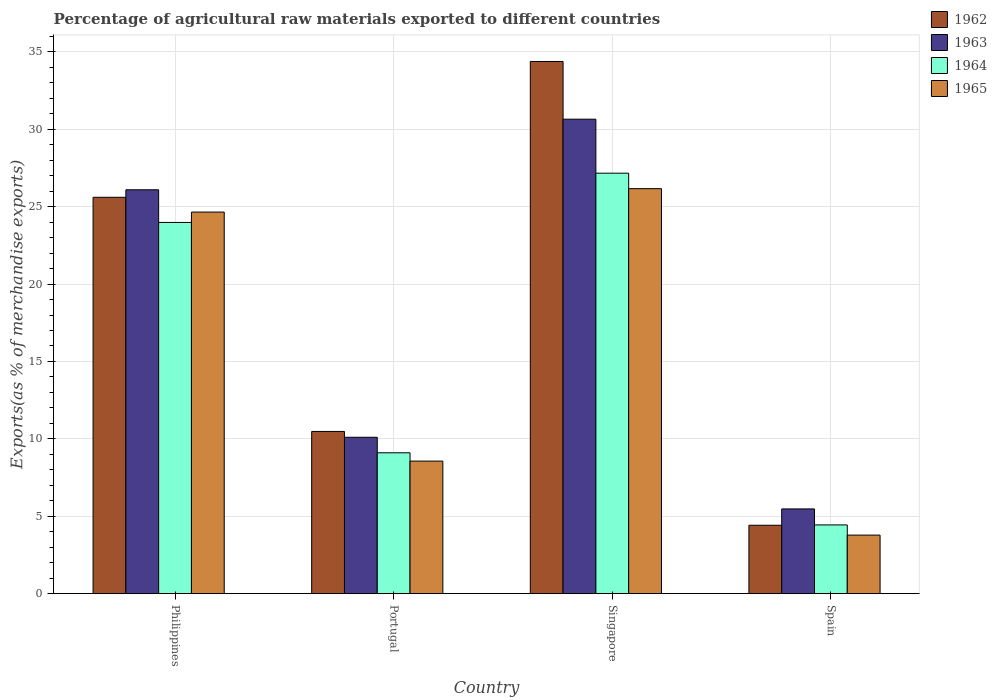Are the number of bars per tick equal to the number of legend labels?
Make the answer very short. Yes. Are the number of bars on each tick of the X-axis equal?
Make the answer very short. Yes. How many bars are there on the 1st tick from the left?
Give a very brief answer. 4. How many bars are there on the 4th tick from the right?
Your response must be concise. 4. What is the label of the 4th group of bars from the left?
Your response must be concise. Spain. In how many cases, is the number of bars for a given country not equal to the number of legend labels?
Provide a succinct answer. 0. What is the percentage of exports to different countries in 1965 in Philippines?
Provide a succinct answer. 24.65. Across all countries, what is the maximum percentage of exports to different countries in 1964?
Ensure brevity in your answer.  27.16. Across all countries, what is the minimum percentage of exports to different countries in 1963?
Ensure brevity in your answer.  5.47. In which country was the percentage of exports to different countries in 1964 maximum?
Ensure brevity in your answer.  Singapore. In which country was the percentage of exports to different countries in 1962 minimum?
Offer a very short reply. Spain. What is the total percentage of exports to different countries in 1962 in the graph?
Your answer should be very brief. 74.88. What is the difference between the percentage of exports to different countries in 1965 in Philippines and that in Spain?
Give a very brief answer. 20.86. What is the difference between the percentage of exports to different countries in 1964 in Singapore and the percentage of exports to different countries in 1962 in Portugal?
Offer a very short reply. 16.68. What is the average percentage of exports to different countries in 1962 per country?
Give a very brief answer. 18.72. What is the difference between the percentage of exports to different countries of/in 1965 and percentage of exports to different countries of/in 1962 in Philippines?
Your answer should be compact. -0.96. In how many countries, is the percentage of exports to different countries in 1965 greater than 29 %?
Your answer should be very brief. 0. What is the ratio of the percentage of exports to different countries in 1962 in Philippines to that in Spain?
Provide a short and direct response. 5.79. Is the difference between the percentage of exports to different countries in 1965 in Philippines and Portugal greater than the difference between the percentage of exports to different countries in 1962 in Philippines and Portugal?
Give a very brief answer. Yes. What is the difference between the highest and the second highest percentage of exports to different countries in 1963?
Keep it short and to the point. 15.99. What is the difference between the highest and the lowest percentage of exports to different countries in 1965?
Your answer should be very brief. 22.38. Is the sum of the percentage of exports to different countries in 1964 in Singapore and Spain greater than the maximum percentage of exports to different countries in 1962 across all countries?
Ensure brevity in your answer.  No. Is it the case that in every country, the sum of the percentage of exports to different countries in 1962 and percentage of exports to different countries in 1964 is greater than the sum of percentage of exports to different countries in 1965 and percentage of exports to different countries in 1963?
Provide a succinct answer. No. What does the 3rd bar from the left in Portugal represents?
Keep it short and to the point. 1964. What does the 3rd bar from the right in Spain represents?
Keep it short and to the point. 1963. Does the graph contain any zero values?
Your response must be concise. No. Where does the legend appear in the graph?
Your response must be concise. Top right. What is the title of the graph?
Provide a succinct answer. Percentage of agricultural raw materials exported to different countries. What is the label or title of the Y-axis?
Your response must be concise. Exports(as % of merchandise exports). What is the Exports(as % of merchandise exports) in 1962 in Philippines?
Provide a short and direct response. 25.6. What is the Exports(as % of merchandise exports) of 1963 in Philippines?
Offer a terse response. 26.09. What is the Exports(as % of merchandise exports) of 1964 in Philippines?
Your response must be concise. 23.98. What is the Exports(as % of merchandise exports) in 1965 in Philippines?
Make the answer very short. 24.65. What is the Exports(as % of merchandise exports) in 1962 in Portugal?
Make the answer very short. 10.48. What is the Exports(as % of merchandise exports) of 1963 in Portugal?
Give a very brief answer. 10.1. What is the Exports(as % of merchandise exports) in 1964 in Portugal?
Your answer should be very brief. 9.1. What is the Exports(as % of merchandise exports) in 1965 in Portugal?
Offer a terse response. 8.56. What is the Exports(as % of merchandise exports) in 1962 in Singapore?
Provide a short and direct response. 34.38. What is the Exports(as % of merchandise exports) of 1963 in Singapore?
Offer a terse response. 30.65. What is the Exports(as % of merchandise exports) of 1964 in Singapore?
Provide a succinct answer. 27.16. What is the Exports(as % of merchandise exports) in 1965 in Singapore?
Provide a short and direct response. 26.16. What is the Exports(as % of merchandise exports) of 1962 in Spain?
Your answer should be compact. 4.42. What is the Exports(as % of merchandise exports) in 1963 in Spain?
Your response must be concise. 5.47. What is the Exports(as % of merchandise exports) in 1964 in Spain?
Offer a very short reply. 4.44. What is the Exports(as % of merchandise exports) of 1965 in Spain?
Offer a very short reply. 3.78. Across all countries, what is the maximum Exports(as % of merchandise exports) in 1962?
Your answer should be very brief. 34.38. Across all countries, what is the maximum Exports(as % of merchandise exports) of 1963?
Offer a terse response. 30.65. Across all countries, what is the maximum Exports(as % of merchandise exports) of 1964?
Keep it short and to the point. 27.16. Across all countries, what is the maximum Exports(as % of merchandise exports) in 1965?
Your response must be concise. 26.16. Across all countries, what is the minimum Exports(as % of merchandise exports) of 1962?
Give a very brief answer. 4.42. Across all countries, what is the minimum Exports(as % of merchandise exports) in 1963?
Give a very brief answer. 5.47. Across all countries, what is the minimum Exports(as % of merchandise exports) of 1964?
Your answer should be very brief. 4.44. Across all countries, what is the minimum Exports(as % of merchandise exports) in 1965?
Provide a short and direct response. 3.78. What is the total Exports(as % of merchandise exports) of 1962 in the graph?
Make the answer very short. 74.88. What is the total Exports(as % of merchandise exports) in 1963 in the graph?
Give a very brief answer. 72.31. What is the total Exports(as % of merchandise exports) in 1964 in the graph?
Ensure brevity in your answer.  64.68. What is the total Exports(as % of merchandise exports) of 1965 in the graph?
Keep it short and to the point. 63.15. What is the difference between the Exports(as % of merchandise exports) of 1962 in Philippines and that in Portugal?
Provide a succinct answer. 15.13. What is the difference between the Exports(as % of merchandise exports) of 1963 in Philippines and that in Portugal?
Provide a short and direct response. 15.99. What is the difference between the Exports(as % of merchandise exports) of 1964 in Philippines and that in Portugal?
Keep it short and to the point. 14.88. What is the difference between the Exports(as % of merchandise exports) in 1965 in Philippines and that in Portugal?
Make the answer very short. 16.08. What is the difference between the Exports(as % of merchandise exports) in 1962 in Philippines and that in Singapore?
Make the answer very short. -8.77. What is the difference between the Exports(as % of merchandise exports) in 1963 in Philippines and that in Singapore?
Keep it short and to the point. -4.56. What is the difference between the Exports(as % of merchandise exports) of 1964 in Philippines and that in Singapore?
Your response must be concise. -3.18. What is the difference between the Exports(as % of merchandise exports) in 1965 in Philippines and that in Singapore?
Provide a succinct answer. -1.51. What is the difference between the Exports(as % of merchandise exports) in 1962 in Philippines and that in Spain?
Your answer should be very brief. 21.19. What is the difference between the Exports(as % of merchandise exports) of 1963 in Philippines and that in Spain?
Ensure brevity in your answer.  20.62. What is the difference between the Exports(as % of merchandise exports) in 1964 in Philippines and that in Spain?
Ensure brevity in your answer.  19.54. What is the difference between the Exports(as % of merchandise exports) in 1965 in Philippines and that in Spain?
Your response must be concise. 20.86. What is the difference between the Exports(as % of merchandise exports) in 1962 in Portugal and that in Singapore?
Offer a terse response. -23.9. What is the difference between the Exports(as % of merchandise exports) in 1963 in Portugal and that in Singapore?
Provide a short and direct response. -20.55. What is the difference between the Exports(as % of merchandise exports) of 1964 in Portugal and that in Singapore?
Offer a terse response. -18.06. What is the difference between the Exports(as % of merchandise exports) of 1965 in Portugal and that in Singapore?
Offer a very short reply. -17.6. What is the difference between the Exports(as % of merchandise exports) in 1962 in Portugal and that in Spain?
Offer a terse response. 6.06. What is the difference between the Exports(as % of merchandise exports) of 1963 in Portugal and that in Spain?
Offer a terse response. 4.63. What is the difference between the Exports(as % of merchandise exports) of 1964 in Portugal and that in Spain?
Ensure brevity in your answer.  4.66. What is the difference between the Exports(as % of merchandise exports) in 1965 in Portugal and that in Spain?
Your response must be concise. 4.78. What is the difference between the Exports(as % of merchandise exports) of 1962 in Singapore and that in Spain?
Offer a very short reply. 29.96. What is the difference between the Exports(as % of merchandise exports) of 1963 in Singapore and that in Spain?
Provide a succinct answer. 25.18. What is the difference between the Exports(as % of merchandise exports) of 1964 in Singapore and that in Spain?
Your answer should be very brief. 22.72. What is the difference between the Exports(as % of merchandise exports) in 1965 in Singapore and that in Spain?
Your answer should be very brief. 22.38. What is the difference between the Exports(as % of merchandise exports) of 1962 in Philippines and the Exports(as % of merchandise exports) of 1963 in Portugal?
Give a very brief answer. 15.5. What is the difference between the Exports(as % of merchandise exports) of 1962 in Philippines and the Exports(as % of merchandise exports) of 1964 in Portugal?
Your answer should be very brief. 16.5. What is the difference between the Exports(as % of merchandise exports) in 1962 in Philippines and the Exports(as % of merchandise exports) in 1965 in Portugal?
Make the answer very short. 17.04. What is the difference between the Exports(as % of merchandise exports) of 1963 in Philippines and the Exports(as % of merchandise exports) of 1964 in Portugal?
Give a very brief answer. 16.99. What is the difference between the Exports(as % of merchandise exports) in 1963 in Philippines and the Exports(as % of merchandise exports) in 1965 in Portugal?
Keep it short and to the point. 17.53. What is the difference between the Exports(as % of merchandise exports) in 1964 in Philippines and the Exports(as % of merchandise exports) in 1965 in Portugal?
Your answer should be very brief. 15.42. What is the difference between the Exports(as % of merchandise exports) of 1962 in Philippines and the Exports(as % of merchandise exports) of 1963 in Singapore?
Offer a very short reply. -5.04. What is the difference between the Exports(as % of merchandise exports) of 1962 in Philippines and the Exports(as % of merchandise exports) of 1964 in Singapore?
Your answer should be very brief. -1.56. What is the difference between the Exports(as % of merchandise exports) in 1962 in Philippines and the Exports(as % of merchandise exports) in 1965 in Singapore?
Your answer should be compact. -0.56. What is the difference between the Exports(as % of merchandise exports) of 1963 in Philippines and the Exports(as % of merchandise exports) of 1964 in Singapore?
Give a very brief answer. -1.07. What is the difference between the Exports(as % of merchandise exports) in 1963 in Philippines and the Exports(as % of merchandise exports) in 1965 in Singapore?
Offer a terse response. -0.07. What is the difference between the Exports(as % of merchandise exports) in 1964 in Philippines and the Exports(as % of merchandise exports) in 1965 in Singapore?
Make the answer very short. -2.18. What is the difference between the Exports(as % of merchandise exports) of 1962 in Philippines and the Exports(as % of merchandise exports) of 1963 in Spain?
Ensure brevity in your answer.  20.13. What is the difference between the Exports(as % of merchandise exports) of 1962 in Philippines and the Exports(as % of merchandise exports) of 1964 in Spain?
Give a very brief answer. 21.16. What is the difference between the Exports(as % of merchandise exports) in 1962 in Philippines and the Exports(as % of merchandise exports) in 1965 in Spain?
Provide a succinct answer. 21.82. What is the difference between the Exports(as % of merchandise exports) of 1963 in Philippines and the Exports(as % of merchandise exports) of 1964 in Spain?
Offer a very short reply. 21.65. What is the difference between the Exports(as % of merchandise exports) of 1963 in Philippines and the Exports(as % of merchandise exports) of 1965 in Spain?
Your answer should be very brief. 22.31. What is the difference between the Exports(as % of merchandise exports) of 1964 in Philippines and the Exports(as % of merchandise exports) of 1965 in Spain?
Offer a very short reply. 20.2. What is the difference between the Exports(as % of merchandise exports) in 1962 in Portugal and the Exports(as % of merchandise exports) in 1963 in Singapore?
Your response must be concise. -20.17. What is the difference between the Exports(as % of merchandise exports) of 1962 in Portugal and the Exports(as % of merchandise exports) of 1964 in Singapore?
Provide a short and direct response. -16.68. What is the difference between the Exports(as % of merchandise exports) of 1962 in Portugal and the Exports(as % of merchandise exports) of 1965 in Singapore?
Your answer should be very brief. -15.68. What is the difference between the Exports(as % of merchandise exports) in 1963 in Portugal and the Exports(as % of merchandise exports) in 1964 in Singapore?
Provide a short and direct response. -17.06. What is the difference between the Exports(as % of merchandise exports) in 1963 in Portugal and the Exports(as % of merchandise exports) in 1965 in Singapore?
Your answer should be compact. -16.06. What is the difference between the Exports(as % of merchandise exports) in 1964 in Portugal and the Exports(as % of merchandise exports) in 1965 in Singapore?
Keep it short and to the point. -17.06. What is the difference between the Exports(as % of merchandise exports) in 1962 in Portugal and the Exports(as % of merchandise exports) in 1963 in Spain?
Your answer should be compact. 5. What is the difference between the Exports(as % of merchandise exports) in 1962 in Portugal and the Exports(as % of merchandise exports) in 1964 in Spain?
Offer a very short reply. 6.04. What is the difference between the Exports(as % of merchandise exports) in 1962 in Portugal and the Exports(as % of merchandise exports) in 1965 in Spain?
Your response must be concise. 6.7. What is the difference between the Exports(as % of merchandise exports) of 1963 in Portugal and the Exports(as % of merchandise exports) of 1964 in Spain?
Your response must be concise. 5.66. What is the difference between the Exports(as % of merchandise exports) in 1963 in Portugal and the Exports(as % of merchandise exports) in 1965 in Spain?
Keep it short and to the point. 6.32. What is the difference between the Exports(as % of merchandise exports) in 1964 in Portugal and the Exports(as % of merchandise exports) in 1965 in Spain?
Make the answer very short. 5.32. What is the difference between the Exports(as % of merchandise exports) of 1962 in Singapore and the Exports(as % of merchandise exports) of 1963 in Spain?
Offer a very short reply. 28.9. What is the difference between the Exports(as % of merchandise exports) of 1962 in Singapore and the Exports(as % of merchandise exports) of 1964 in Spain?
Your answer should be compact. 29.94. What is the difference between the Exports(as % of merchandise exports) of 1962 in Singapore and the Exports(as % of merchandise exports) of 1965 in Spain?
Your answer should be very brief. 30.59. What is the difference between the Exports(as % of merchandise exports) in 1963 in Singapore and the Exports(as % of merchandise exports) in 1964 in Spain?
Keep it short and to the point. 26.21. What is the difference between the Exports(as % of merchandise exports) of 1963 in Singapore and the Exports(as % of merchandise exports) of 1965 in Spain?
Offer a terse response. 26.87. What is the difference between the Exports(as % of merchandise exports) in 1964 in Singapore and the Exports(as % of merchandise exports) in 1965 in Spain?
Your answer should be compact. 23.38. What is the average Exports(as % of merchandise exports) in 1962 per country?
Provide a short and direct response. 18.72. What is the average Exports(as % of merchandise exports) of 1963 per country?
Your answer should be compact. 18.08. What is the average Exports(as % of merchandise exports) of 1964 per country?
Provide a succinct answer. 16.17. What is the average Exports(as % of merchandise exports) in 1965 per country?
Provide a short and direct response. 15.79. What is the difference between the Exports(as % of merchandise exports) of 1962 and Exports(as % of merchandise exports) of 1963 in Philippines?
Give a very brief answer. -0.49. What is the difference between the Exports(as % of merchandise exports) of 1962 and Exports(as % of merchandise exports) of 1964 in Philippines?
Provide a short and direct response. 1.63. What is the difference between the Exports(as % of merchandise exports) of 1962 and Exports(as % of merchandise exports) of 1965 in Philippines?
Ensure brevity in your answer.  0.96. What is the difference between the Exports(as % of merchandise exports) of 1963 and Exports(as % of merchandise exports) of 1964 in Philippines?
Your answer should be compact. 2.11. What is the difference between the Exports(as % of merchandise exports) of 1963 and Exports(as % of merchandise exports) of 1965 in Philippines?
Provide a succinct answer. 1.44. What is the difference between the Exports(as % of merchandise exports) in 1964 and Exports(as % of merchandise exports) in 1965 in Philippines?
Provide a short and direct response. -0.67. What is the difference between the Exports(as % of merchandise exports) in 1962 and Exports(as % of merchandise exports) in 1963 in Portugal?
Your answer should be compact. 0.38. What is the difference between the Exports(as % of merchandise exports) in 1962 and Exports(as % of merchandise exports) in 1964 in Portugal?
Ensure brevity in your answer.  1.38. What is the difference between the Exports(as % of merchandise exports) in 1962 and Exports(as % of merchandise exports) in 1965 in Portugal?
Give a very brief answer. 1.92. What is the difference between the Exports(as % of merchandise exports) in 1963 and Exports(as % of merchandise exports) in 1964 in Portugal?
Provide a succinct answer. 1. What is the difference between the Exports(as % of merchandise exports) of 1963 and Exports(as % of merchandise exports) of 1965 in Portugal?
Ensure brevity in your answer.  1.54. What is the difference between the Exports(as % of merchandise exports) of 1964 and Exports(as % of merchandise exports) of 1965 in Portugal?
Offer a terse response. 0.54. What is the difference between the Exports(as % of merchandise exports) in 1962 and Exports(as % of merchandise exports) in 1963 in Singapore?
Offer a very short reply. 3.73. What is the difference between the Exports(as % of merchandise exports) of 1962 and Exports(as % of merchandise exports) of 1964 in Singapore?
Give a very brief answer. 7.22. What is the difference between the Exports(as % of merchandise exports) of 1962 and Exports(as % of merchandise exports) of 1965 in Singapore?
Keep it short and to the point. 8.22. What is the difference between the Exports(as % of merchandise exports) of 1963 and Exports(as % of merchandise exports) of 1964 in Singapore?
Keep it short and to the point. 3.49. What is the difference between the Exports(as % of merchandise exports) in 1963 and Exports(as % of merchandise exports) in 1965 in Singapore?
Provide a short and direct response. 4.49. What is the difference between the Exports(as % of merchandise exports) in 1964 and Exports(as % of merchandise exports) in 1965 in Singapore?
Give a very brief answer. 1. What is the difference between the Exports(as % of merchandise exports) of 1962 and Exports(as % of merchandise exports) of 1963 in Spain?
Provide a short and direct response. -1.06. What is the difference between the Exports(as % of merchandise exports) of 1962 and Exports(as % of merchandise exports) of 1964 in Spain?
Make the answer very short. -0.02. What is the difference between the Exports(as % of merchandise exports) of 1962 and Exports(as % of merchandise exports) of 1965 in Spain?
Offer a very short reply. 0.64. What is the difference between the Exports(as % of merchandise exports) of 1963 and Exports(as % of merchandise exports) of 1964 in Spain?
Keep it short and to the point. 1.03. What is the difference between the Exports(as % of merchandise exports) in 1963 and Exports(as % of merchandise exports) in 1965 in Spain?
Give a very brief answer. 1.69. What is the difference between the Exports(as % of merchandise exports) of 1964 and Exports(as % of merchandise exports) of 1965 in Spain?
Give a very brief answer. 0.66. What is the ratio of the Exports(as % of merchandise exports) of 1962 in Philippines to that in Portugal?
Make the answer very short. 2.44. What is the ratio of the Exports(as % of merchandise exports) of 1963 in Philippines to that in Portugal?
Provide a succinct answer. 2.58. What is the ratio of the Exports(as % of merchandise exports) of 1964 in Philippines to that in Portugal?
Offer a terse response. 2.64. What is the ratio of the Exports(as % of merchandise exports) in 1965 in Philippines to that in Portugal?
Your response must be concise. 2.88. What is the ratio of the Exports(as % of merchandise exports) of 1962 in Philippines to that in Singapore?
Your response must be concise. 0.74. What is the ratio of the Exports(as % of merchandise exports) in 1963 in Philippines to that in Singapore?
Keep it short and to the point. 0.85. What is the ratio of the Exports(as % of merchandise exports) of 1964 in Philippines to that in Singapore?
Your answer should be compact. 0.88. What is the ratio of the Exports(as % of merchandise exports) of 1965 in Philippines to that in Singapore?
Keep it short and to the point. 0.94. What is the ratio of the Exports(as % of merchandise exports) in 1962 in Philippines to that in Spain?
Provide a succinct answer. 5.79. What is the ratio of the Exports(as % of merchandise exports) in 1963 in Philippines to that in Spain?
Ensure brevity in your answer.  4.77. What is the ratio of the Exports(as % of merchandise exports) in 1964 in Philippines to that in Spain?
Provide a short and direct response. 5.4. What is the ratio of the Exports(as % of merchandise exports) in 1965 in Philippines to that in Spain?
Your response must be concise. 6.52. What is the ratio of the Exports(as % of merchandise exports) in 1962 in Portugal to that in Singapore?
Give a very brief answer. 0.3. What is the ratio of the Exports(as % of merchandise exports) in 1963 in Portugal to that in Singapore?
Make the answer very short. 0.33. What is the ratio of the Exports(as % of merchandise exports) of 1964 in Portugal to that in Singapore?
Provide a short and direct response. 0.34. What is the ratio of the Exports(as % of merchandise exports) in 1965 in Portugal to that in Singapore?
Make the answer very short. 0.33. What is the ratio of the Exports(as % of merchandise exports) of 1962 in Portugal to that in Spain?
Provide a succinct answer. 2.37. What is the ratio of the Exports(as % of merchandise exports) in 1963 in Portugal to that in Spain?
Provide a short and direct response. 1.85. What is the ratio of the Exports(as % of merchandise exports) in 1964 in Portugal to that in Spain?
Your answer should be very brief. 2.05. What is the ratio of the Exports(as % of merchandise exports) in 1965 in Portugal to that in Spain?
Give a very brief answer. 2.26. What is the ratio of the Exports(as % of merchandise exports) of 1962 in Singapore to that in Spain?
Keep it short and to the point. 7.78. What is the ratio of the Exports(as % of merchandise exports) of 1963 in Singapore to that in Spain?
Ensure brevity in your answer.  5.6. What is the ratio of the Exports(as % of merchandise exports) of 1964 in Singapore to that in Spain?
Provide a short and direct response. 6.12. What is the ratio of the Exports(as % of merchandise exports) of 1965 in Singapore to that in Spain?
Offer a terse response. 6.92. What is the difference between the highest and the second highest Exports(as % of merchandise exports) in 1962?
Give a very brief answer. 8.77. What is the difference between the highest and the second highest Exports(as % of merchandise exports) of 1963?
Keep it short and to the point. 4.56. What is the difference between the highest and the second highest Exports(as % of merchandise exports) in 1964?
Your answer should be compact. 3.18. What is the difference between the highest and the second highest Exports(as % of merchandise exports) in 1965?
Your response must be concise. 1.51. What is the difference between the highest and the lowest Exports(as % of merchandise exports) of 1962?
Provide a short and direct response. 29.96. What is the difference between the highest and the lowest Exports(as % of merchandise exports) of 1963?
Make the answer very short. 25.18. What is the difference between the highest and the lowest Exports(as % of merchandise exports) in 1964?
Offer a terse response. 22.72. What is the difference between the highest and the lowest Exports(as % of merchandise exports) in 1965?
Make the answer very short. 22.38. 